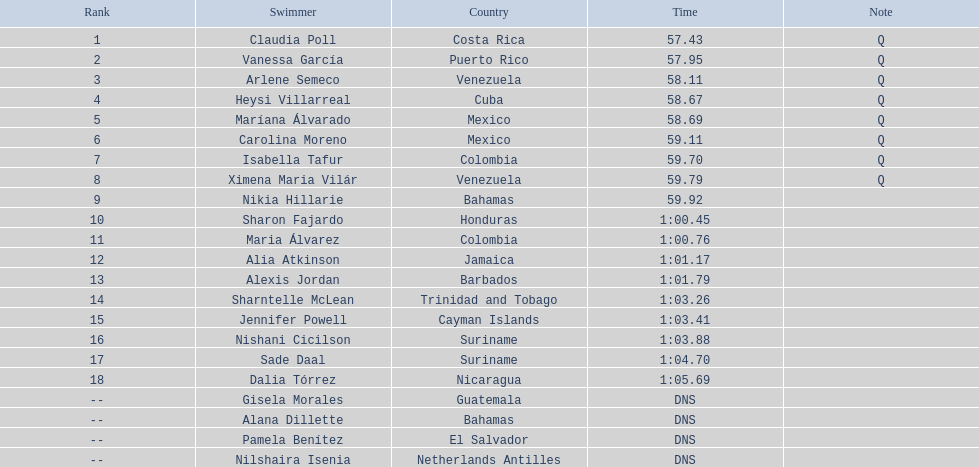Who was the last competitor to actually finish the preliminaries? Dalia Tórrez. 